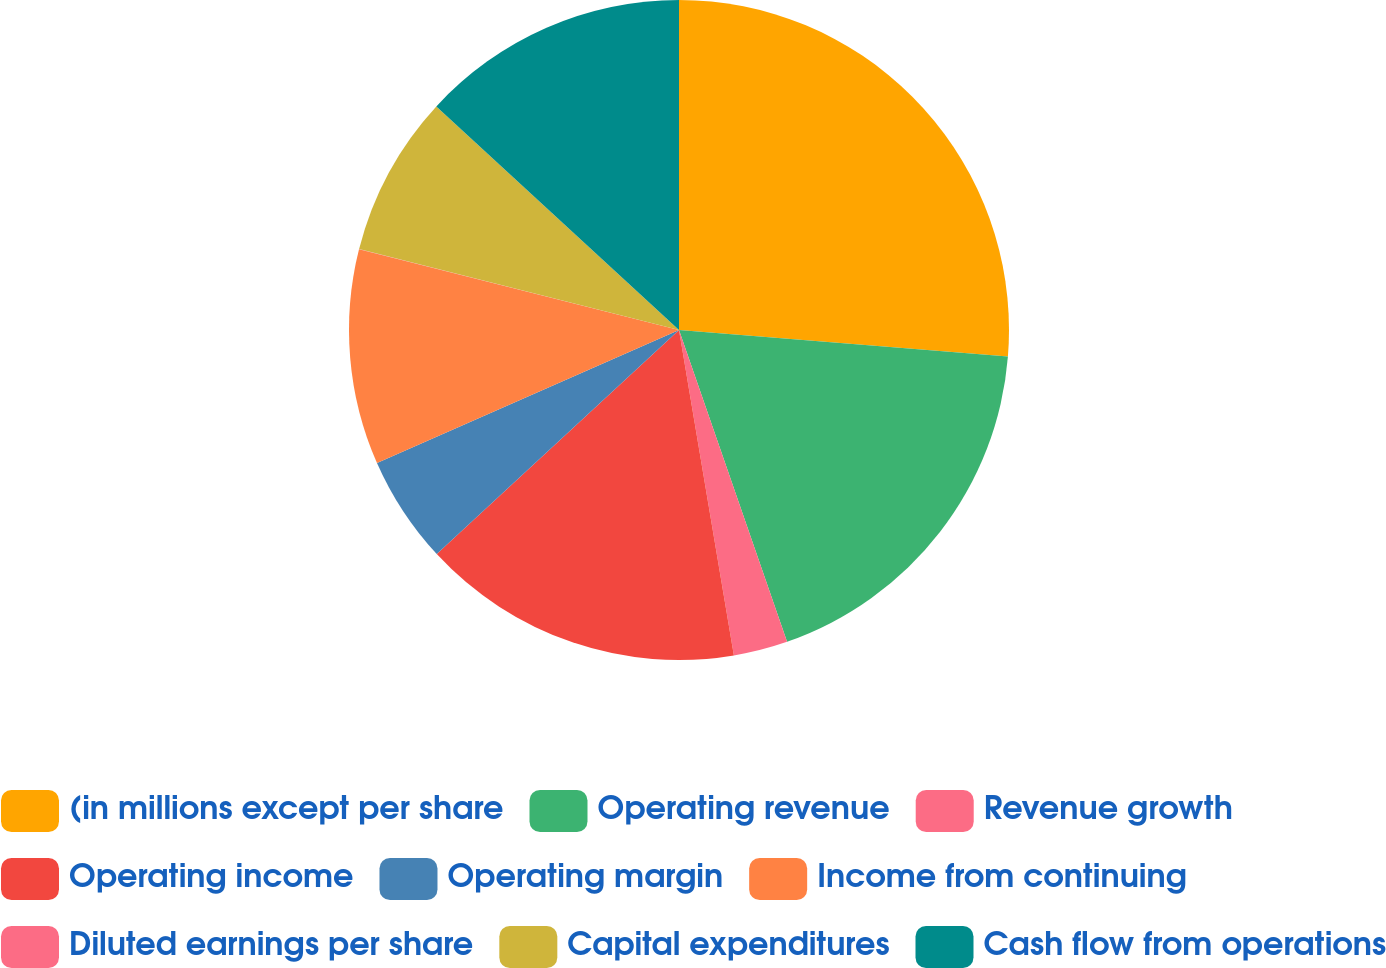Convert chart. <chart><loc_0><loc_0><loc_500><loc_500><pie_chart><fcel>(in millions except per share<fcel>Operating revenue<fcel>Revenue growth<fcel>Operating income<fcel>Operating margin<fcel>Income from continuing<fcel>Diluted earnings per share<fcel>Capital expenditures<fcel>Cash flow from operations<nl><fcel>26.28%<fcel>18.41%<fcel>2.65%<fcel>15.78%<fcel>5.28%<fcel>10.53%<fcel>0.02%<fcel>7.9%<fcel>13.15%<nl></chart> 